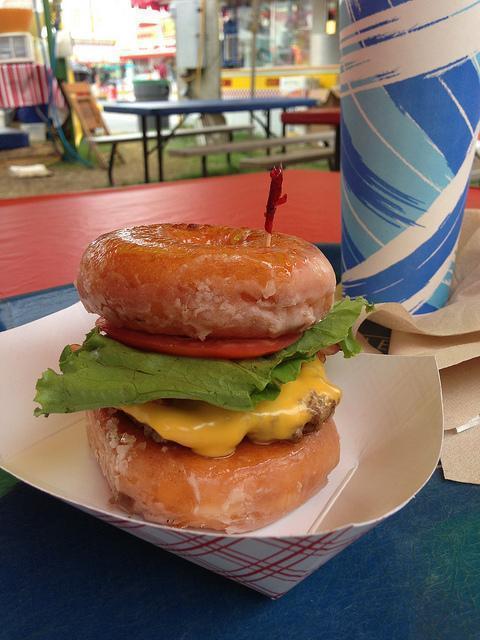What is the most unhealthy part of this cheeseburger?
Choose the correct response, then elucidate: 'Answer: answer
Rationale: rationale.'
Options: Donut bun, lettuce, beef, cheese. Answer: donut bun.
Rationale: The donut bun has a lot of sugar. 